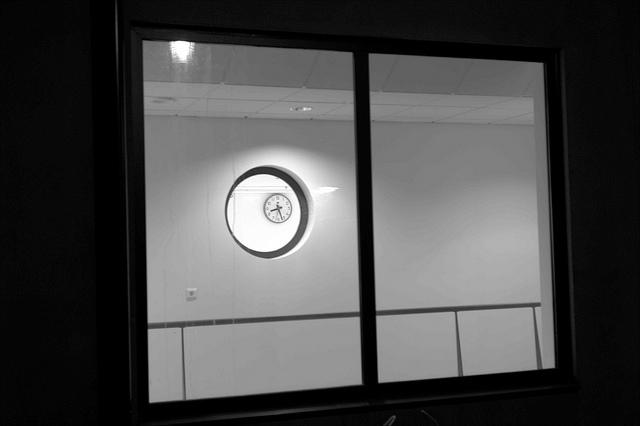What time of day is it?
Answer briefly. 8:25. Would a nearsighted person be able to see the clock?
Answer briefly. No. What time is it?
Give a very brief answer. 8:25. Is that a clock on the background?
Quick response, please. Yes. What is to the right of the clock?
Answer briefly. Wall. 